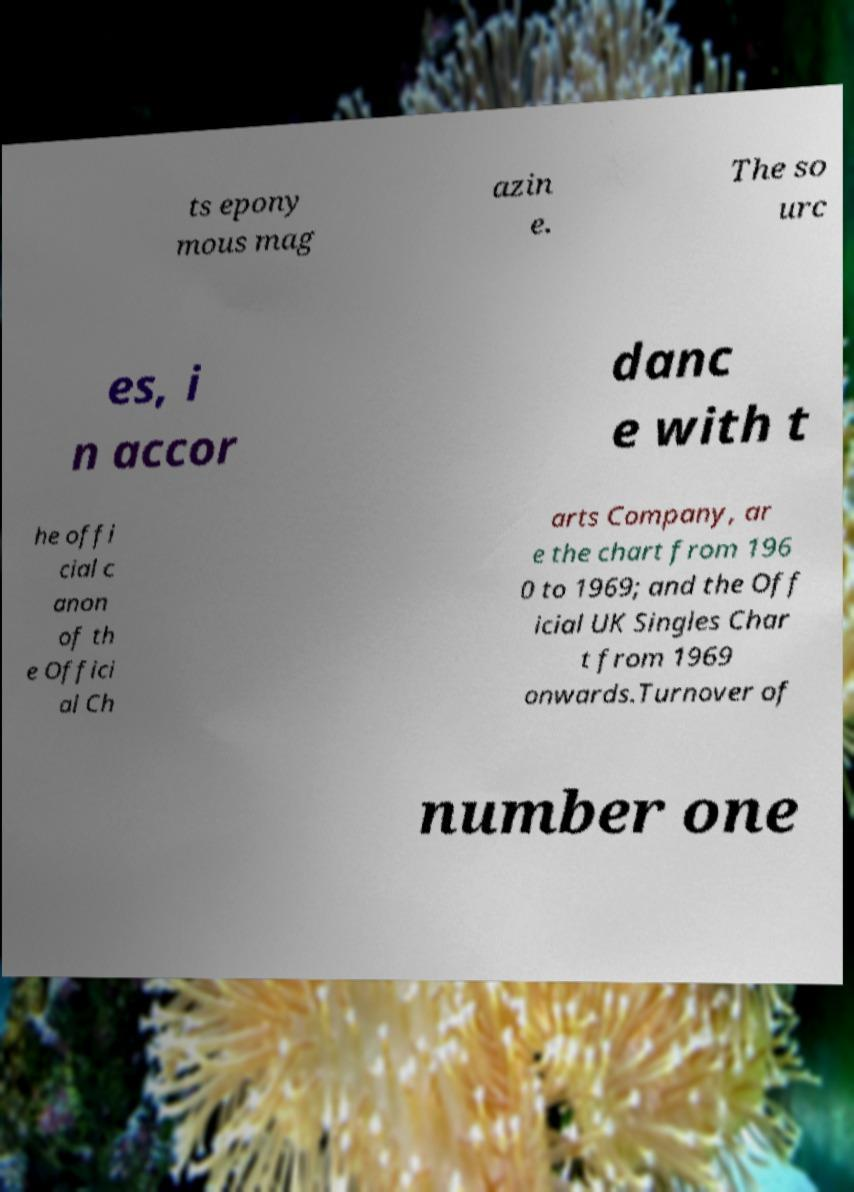I need the written content from this picture converted into text. Can you do that? ts epony mous mag azin e. The so urc es, i n accor danc e with t he offi cial c anon of th e Offici al Ch arts Company, ar e the chart from 196 0 to 1969; and the Off icial UK Singles Char t from 1969 onwards.Turnover of number one 